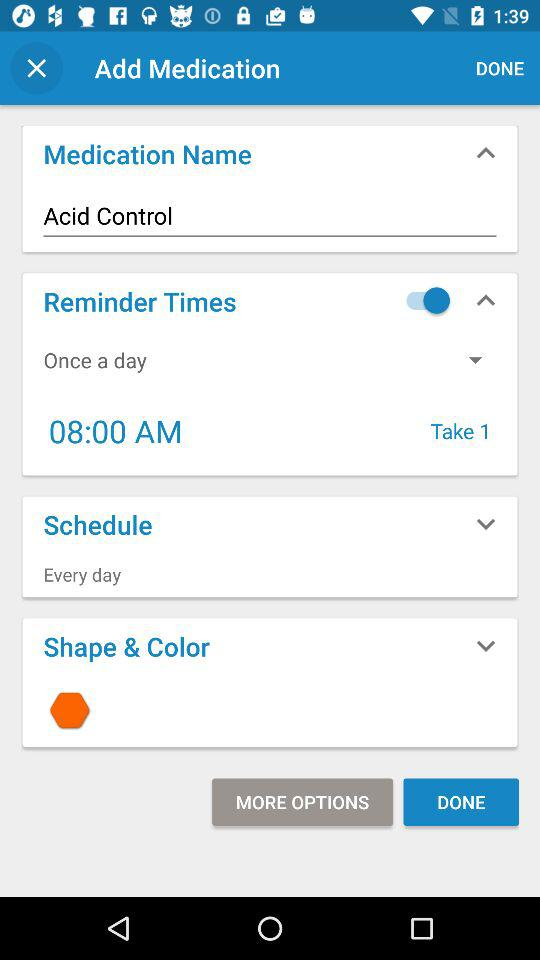When was it scheduled to be consumed?
When the provided information is insufficient, respond with <no answer>. <no answer> 